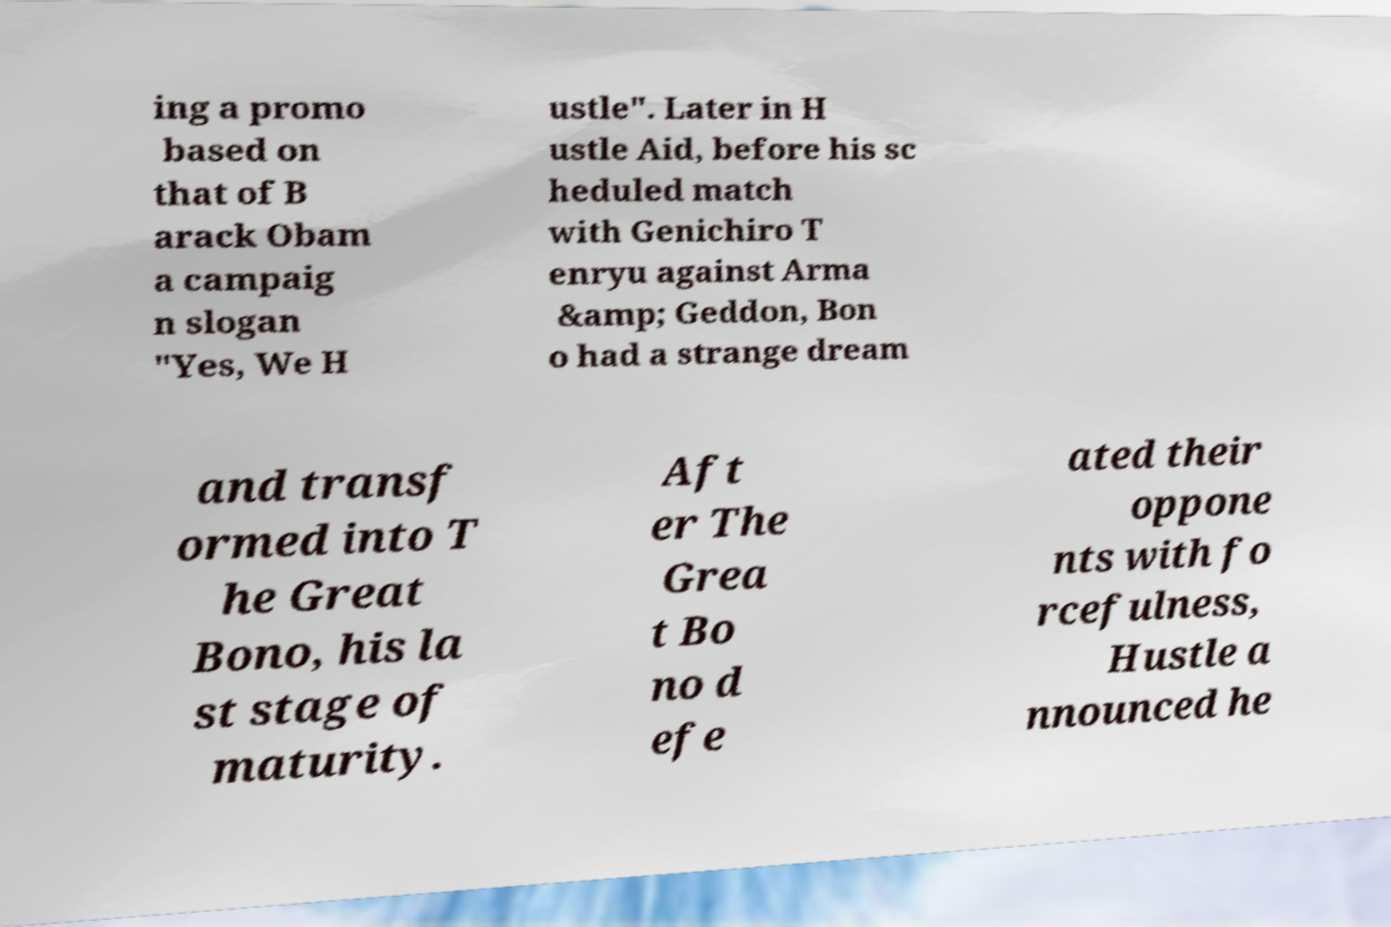What messages or text are displayed in this image? I need them in a readable, typed format. ing a promo based on that of B arack Obam a campaig n slogan "Yes, We H ustle". Later in H ustle Aid, before his sc heduled match with Genichiro T enryu against Arma &amp; Geddon, Bon o had a strange dream and transf ormed into T he Great Bono, his la st stage of maturity. Aft er The Grea t Bo no d efe ated their oppone nts with fo rcefulness, Hustle a nnounced he 